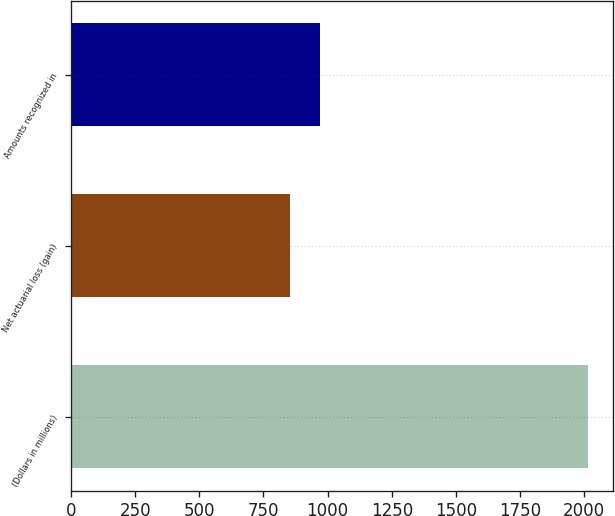Convert chart. <chart><loc_0><loc_0><loc_500><loc_500><bar_chart><fcel>(Dollars in millions)<fcel>Net actuarial loss (gain)<fcel>Amounts recognized in<nl><fcel>2013<fcel>855<fcel>970.8<nl></chart> 